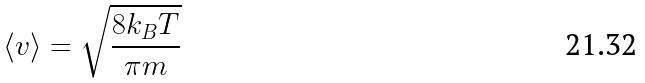<formula> <loc_0><loc_0><loc_500><loc_500>\langle v \rangle = \sqrt { \frac { 8 k _ { B } T } { \pi m } }</formula> 